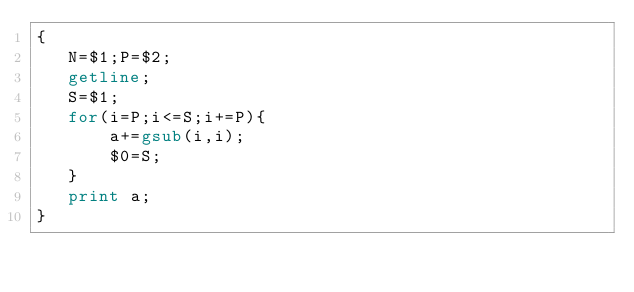<code> <loc_0><loc_0><loc_500><loc_500><_Awk_>{
   N=$1;P=$2;
   getline;
   S=$1;
   for(i=P;i<=S;i+=P){
       a+=gsub(i,i);
       $0=S;
   }
   print a;
}</code> 